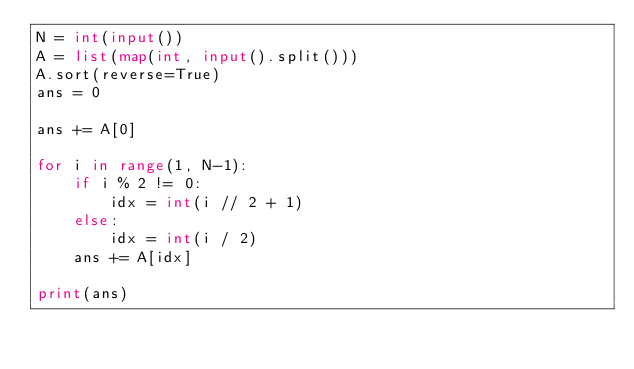Convert code to text. <code><loc_0><loc_0><loc_500><loc_500><_Python_>N = int(input())
A = list(map(int, input().split()))
A.sort(reverse=True)
ans = 0

ans += A[0]

for i in range(1, N-1):
    if i % 2 != 0:
        idx = int(i // 2 + 1)
    else:
        idx = int(i / 2)
    ans += A[idx]

print(ans)
</code> 